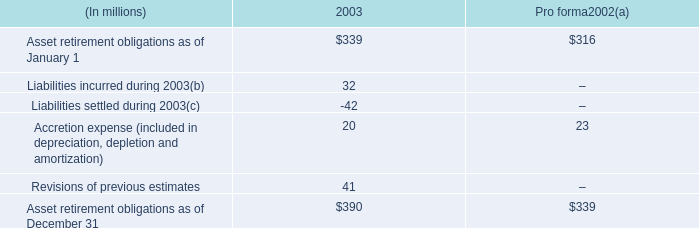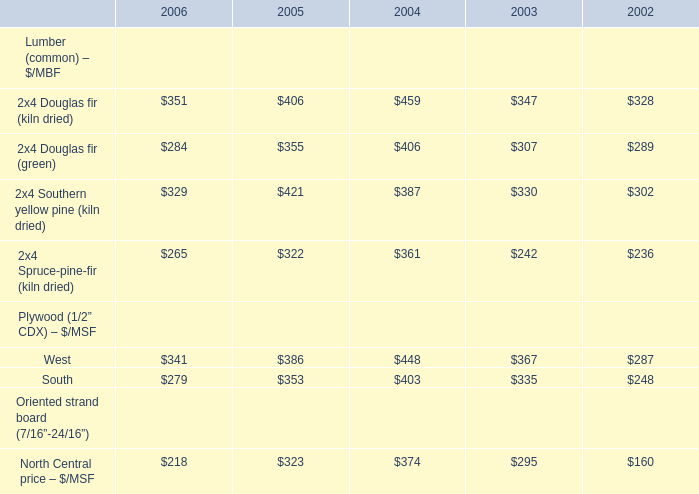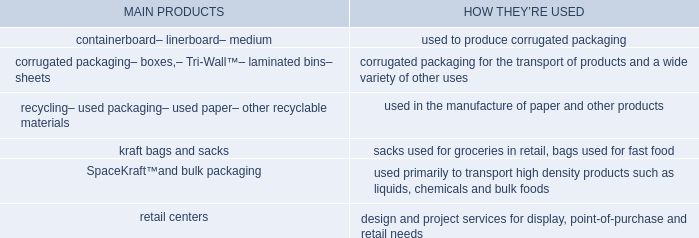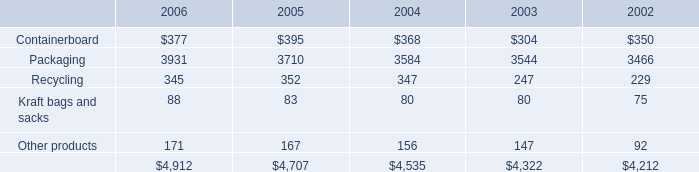Does the value of 2x4 Douglas fir (kiln dried) in 2006 greater than that in 2005? 
Answer: no. 